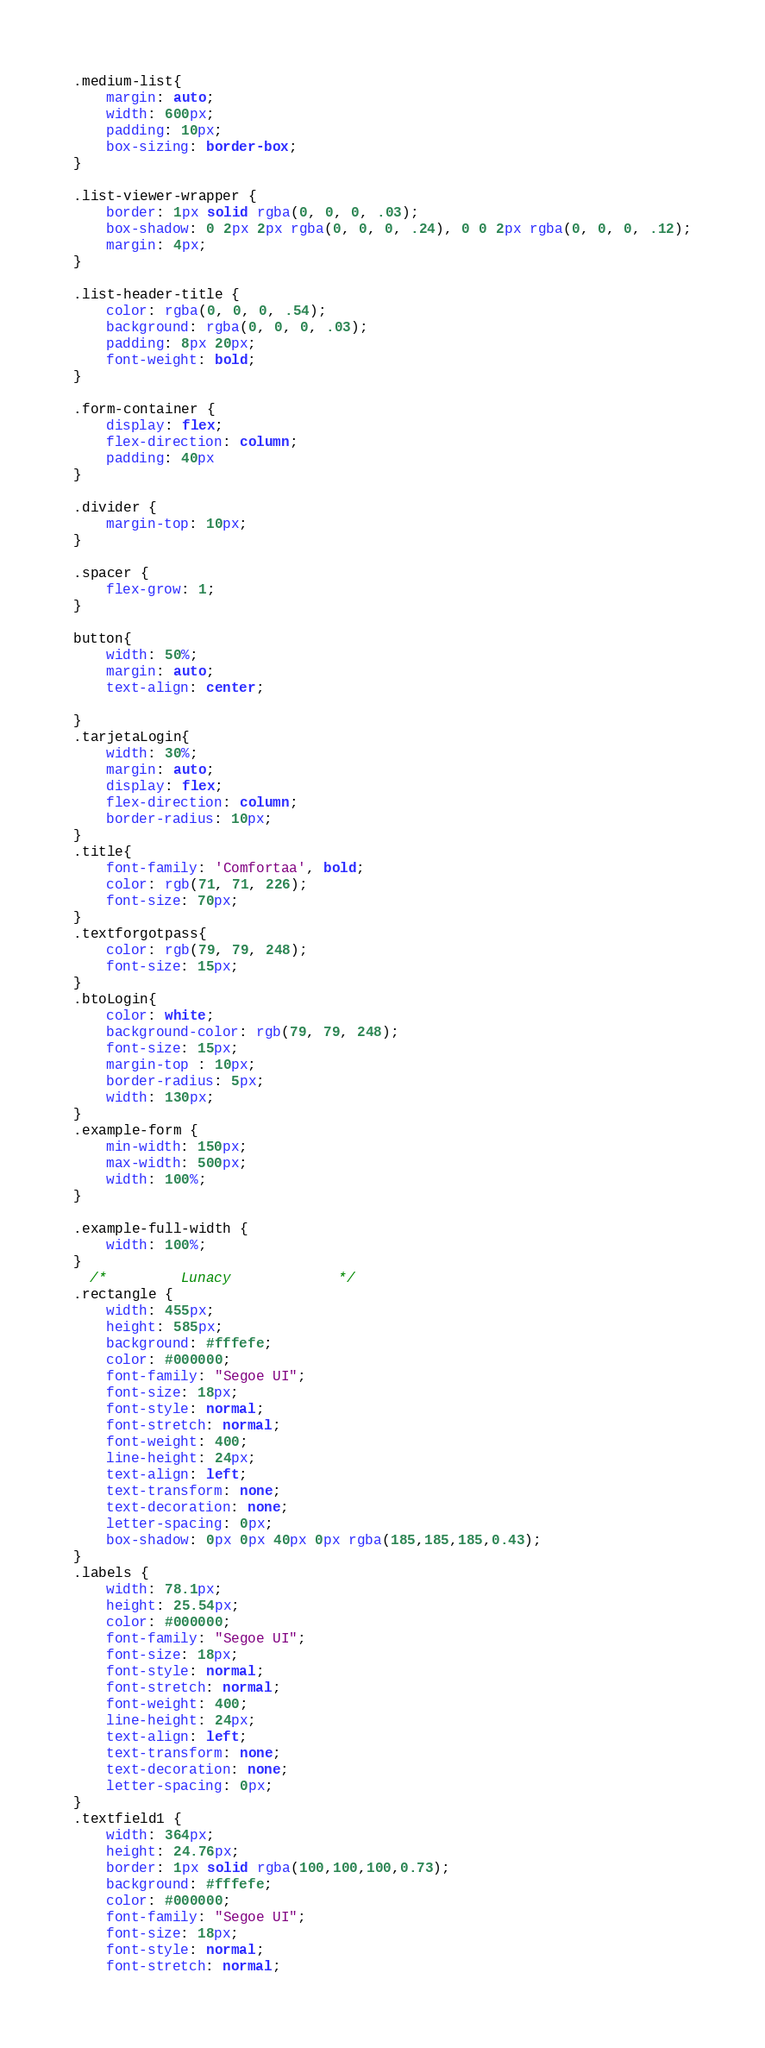Convert code to text. <code><loc_0><loc_0><loc_500><loc_500><_CSS_>.medium-list{
    margin: auto;
    width: 600px;
    padding: 10px;
    box-sizing: border-box;
}
    
.list-viewer-wrapper {
    border: 1px solid rgba(0, 0, 0, .03);
    box-shadow: 0 2px 2px rgba(0, 0, 0, .24), 0 0 2px rgba(0, 0, 0, .12);
    margin: 4px;
}

.list-header-title {
    color: rgba(0, 0, 0, .54);
    background: rgba(0, 0, 0, .03);
    padding: 8px 20px;
    font-weight: bold;
}

.form-container {
    display: flex;
    flex-direction: column;
    padding: 40px
}

.divider {
    margin-top: 10px; 
}

.spacer {
    flex-grow: 1;
}

button{
    width: 50%;
    margin: auto;
    text-align: center;
   
}
.tarjetaLogin{
    width: 30%;
    margin: auto;
    display: flex;
    flex-direction: column;
    border-radius: 10px;
}
.title{
    font-family: 'Comfortaa', bold;
    color: rgb(71, 71, 226);
    font-size: 70px;
}
.textforgotpass{   
    color: rgb(79, 79, 248);
    font-size: 15px;
}
.btoLogin{
    color: white;
    background-color: rgb(79, 79, 248);
    font-size: 15px;
    margin-top : 10px;
    border-radius: 5px;
    width: 130px;
}
.example-form {
    min-width: 150px;
    max-width: 500px;
    width: 100%;
}
  
.example-full-width {
    width: 100%;
}
  /*         Lunacy             */
.rectangle {
    width: 455px;
    height: 585px;
    background: #fffefe;
    color: #000000;
    font-family: "Segoe UI";
    font-size: 18px;
    font-style: normal;
    font-stretch: normal;
    font-weight: 400;
    line-height: 24px;
    text-align: left;
    text-transform: none;
    text-decoration: none;
    letter-spacing: 0px;
    box-shadow: 0px 0px 40px 0px rgba(185,185,185,0.43);
}
.labels {
    width: 78.1px;
    height: 25.54px;
    color: #000000;
    font-family: "Segoe UI";
    font-size: 18px;
    font-style: normal;
    font-stretch: normal;
    font-weight: 400;
    line-height: 24px;
    text-align: left;
    text-transform: none;
    text-decoration: none;
    letter-spacing: 0px;
}
.textfield1 {
    width: 364px;
    height: 24.76px;
    border: 1px solid rgba(100,100,100,0.73);
    background: #fffefe;
    color: #000000;
    font-family: "Segoe UI";
    font-size: 18px;
    font-style: normal;
    font-stretch: normal;</code> 